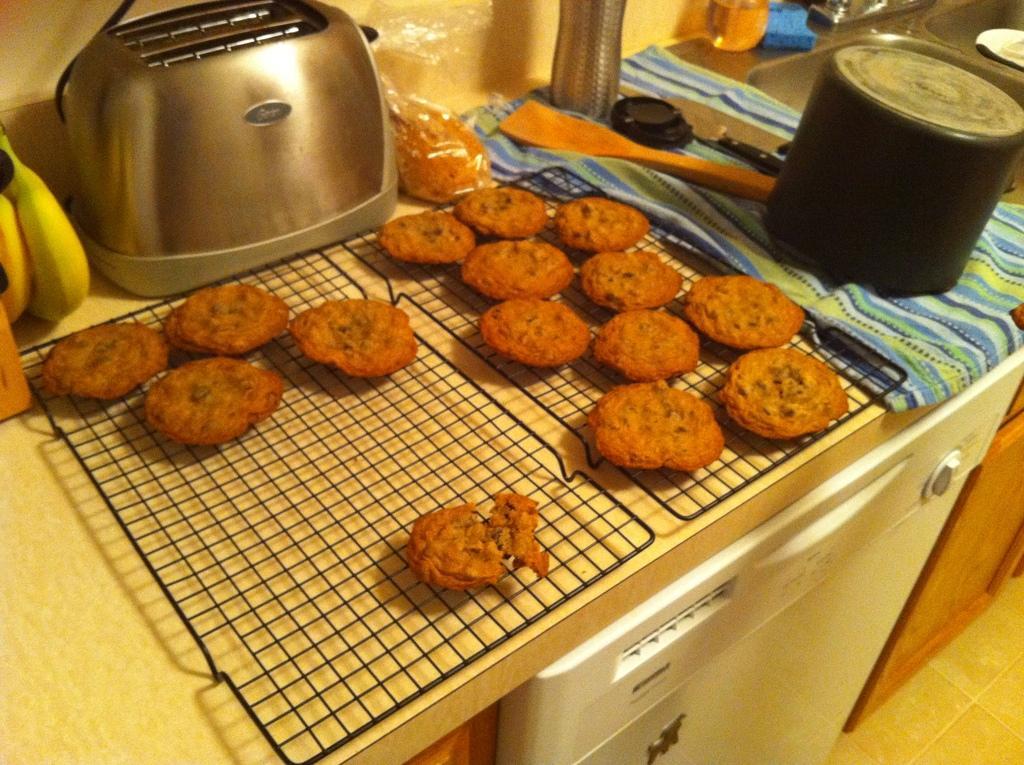In one or two sentences, can you explain what this image depicts? In this image we can see some baked cookies on a grill. We can also see a toaster, bananas, a cover, spatula, bottles, container and a sponge which are placed on the table. We can also see an electronic device and a sink. 